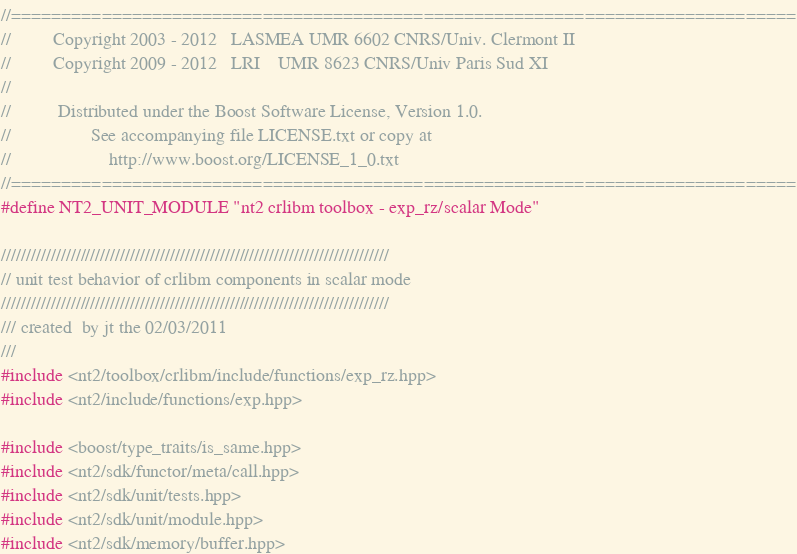Convert code to text. <code><loc_0><loc_0><loc_500><loc_500><_C++_>//==============================================================================
//         Copyright 2003 - 2012   LASMEA UMR 6602 CNRS/Univ. Clermont II
//         Copyright 2009 - 2012   LRI    UMR 8623 CNRS/Univ Paris Sud XI
//
//          Distributed under the Boost Software License, Version 1.0.
//                 See accompanying file LICENSE.txt or copy at
//                     http://www.boost.org/LICENSE_1_0.txt
//==============================================================================
#define NT2_UNIT_MODULE "nt2 crlibm toolbox - exp_rz/scalar Mode"

//////////////////////////////////////////////////////////////////////////////
// unit test behavior of crlibm components in scalar mode
//////////////////////////////////////////////////////////////////////////////
/// created  by jt the 02/03/2011
///
#include <nt2/toolbox/crlibm/include/functions/exp_rz.hpp>
#include <nt2/include/functions/exp.hpp>

#include <boost/type_traits/is_same.hpp>
#include <nt2/sdk/functor/meta/call.hpp>
#include <nt2/sdk/unit/tests.hpp>
#include <nt2/sdk/unit/module.hpp>
#include <nt2/sdk/memory/buffer.hpp></code> 